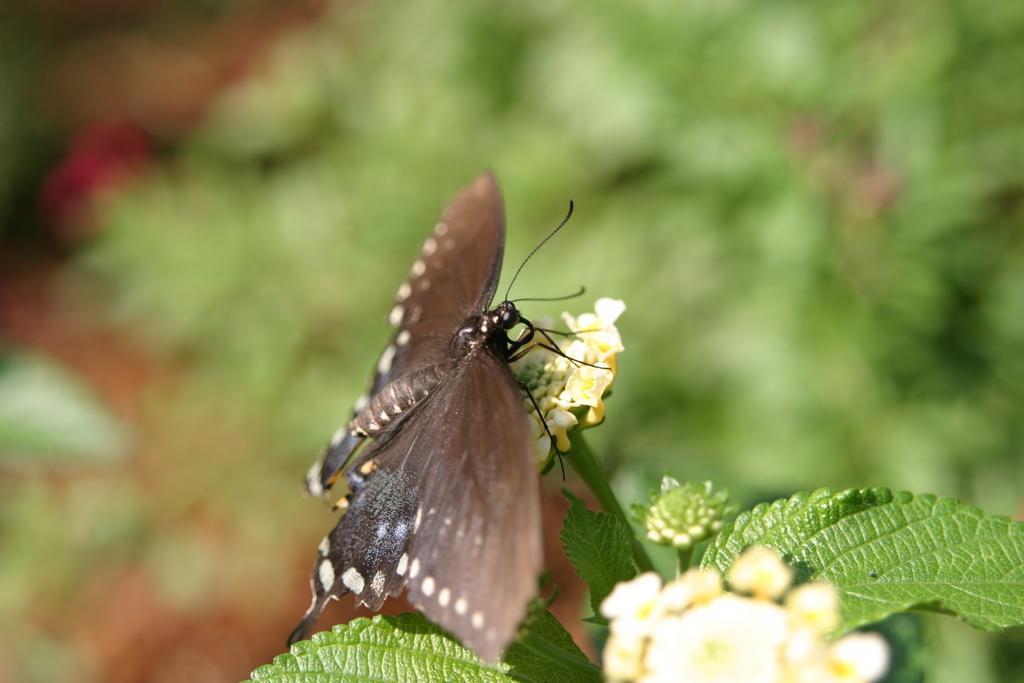Describe this image in one or two sentences. In the center of the image there is a butterfly on the plant. 